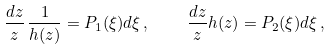<formula> <loc_0><loc_0><loc_500><loc_500>\frac { d z } { z } \, \frac { 1 } { h ( z ) } = P _ { 1 } ( \xi ) d \xi \, , \quad \frac { d z } { z } h ( z ) = P _ { 2 } ( \xi ) d \xi \, ,</formula> 